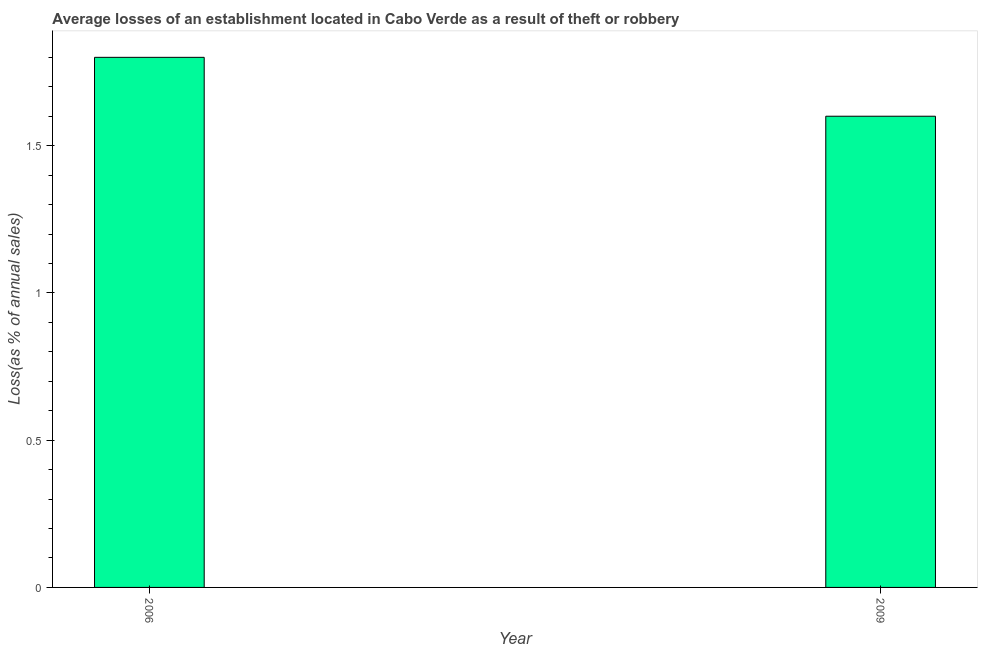What is the title of the graph?
Offer a very short reply. Average losses of an establishment located in Cabo Verde as a result of theft or robbery. What is the label or title of the Y-axis?
Your response must be concise. Loss(as % of annual sales). Across all years, what is the maximum losses due to theft?
Provide a short and direct response. 1.8. Across all years, what is the minimum losses due to theft?
Your response must be concise. 1.6. What is the sum of the losses due to theft?
Your response must be concise. 3.4. What is the average losses due to theft per year?
Your answer should be very brief. 1.7. What is the median losses due to theft?
Give a very brief answer. 1.7. In how many years, is the losses due to theft greater than 0.3 %?
Your response must be concise. 2. Do a majority of the years between 2009 and 2006 (inclusive) have losses due to theft greater than 1.5 %?
Offer a terse response. No. What is the ratio of the losses due to theft in 2006 to that in 2009?
Offer a very short reply. 1.12. Is the losses due to theft in 2006 less than that in 2009?
Offer a very short reply. No. Are all the bars in the graph horizontal?
Keep it short and to the point. No. What is the difference between two consecutive major ticks on the Y-axis?
Keep it short and to the point. 0.5. What is the ratio of the Loss(as % of annual sales) in 2006 to that in 2009?
Offer a very short reply. 1.12. 